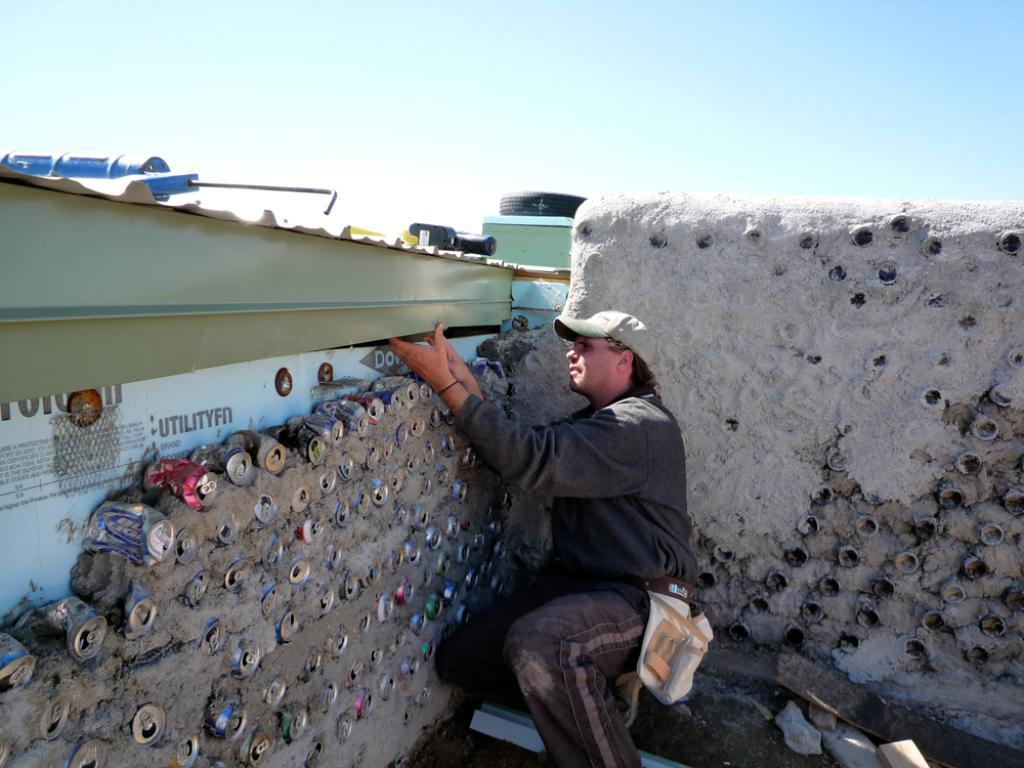<image>
Write a terse but informative summary of the picture. A bunch of beer cans buried under a wall which has the text utilityfn 